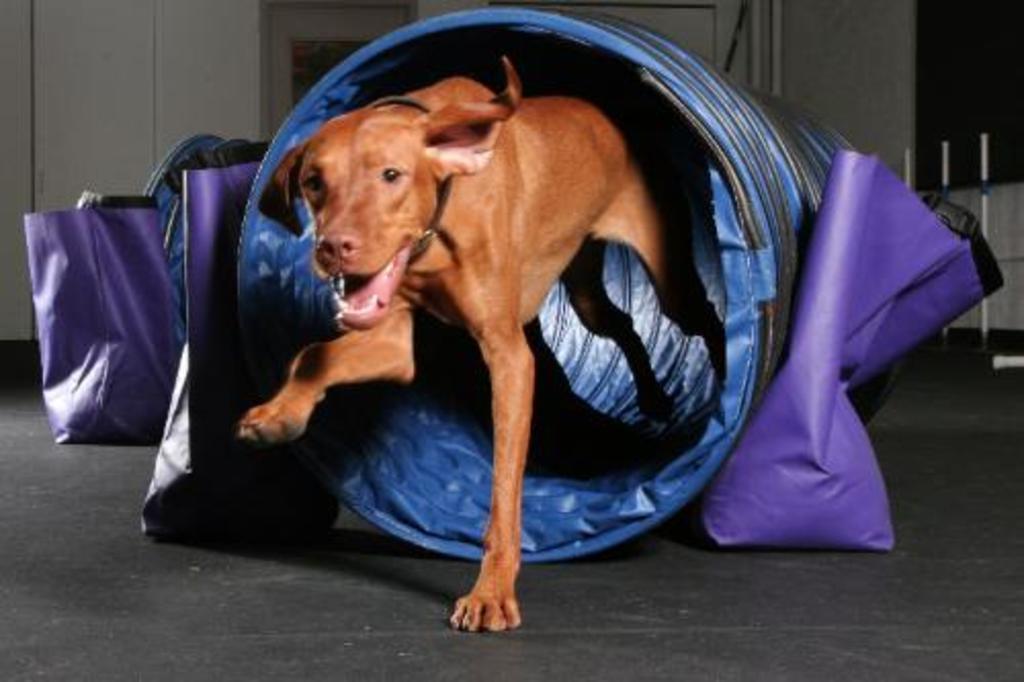How would you summarize this image in a sentence or two? In this image I can see a dog in a blue color object. Here I can see some bags and other objects on the floor. In the background I can see a wall. 